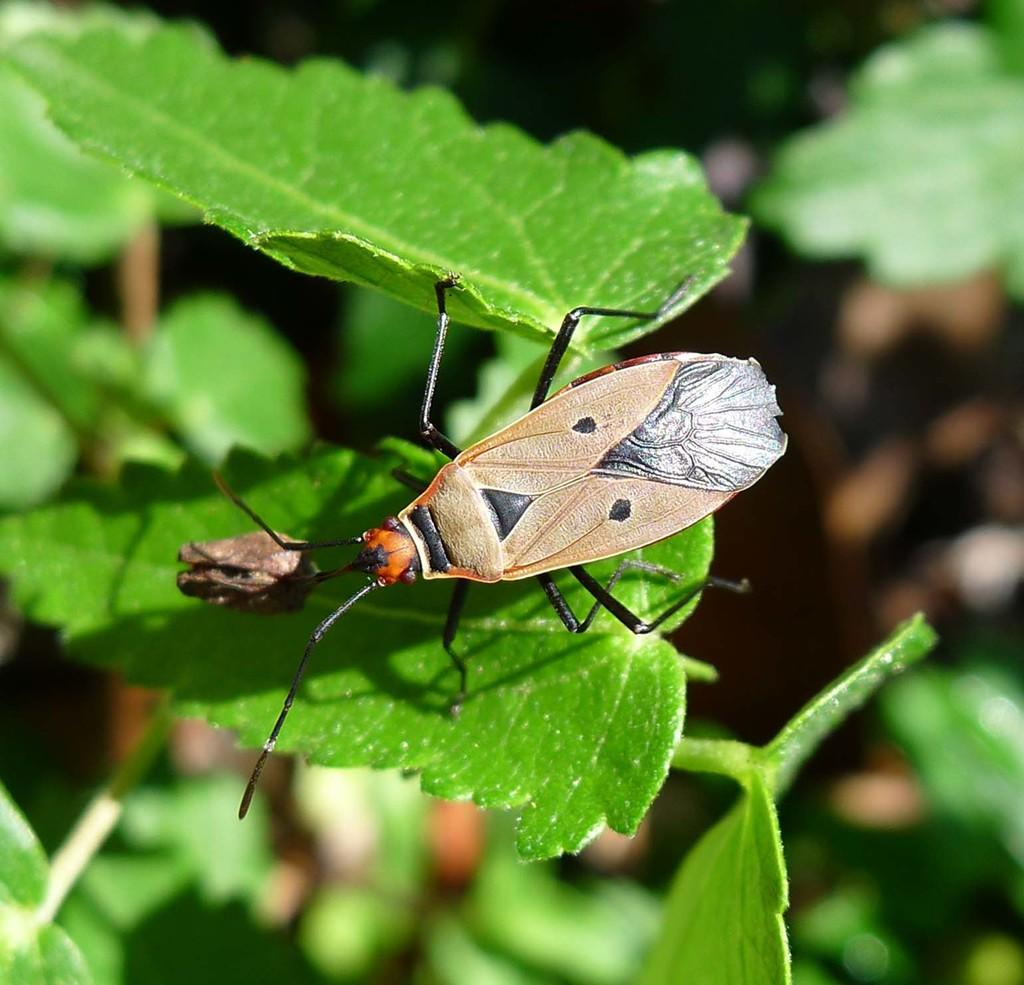What is on the leaf in the image? There is a fly on a leaf in the image. What can be seen on the left side of the image? There is a plant on the left side of the image. What type of cheese is visible on the leaf in the image? There is no cheese present in the image; it features a fly on a leaf. What details can be seen on the fly in the image? The image does not provide enough detail to describe the fly's features. 